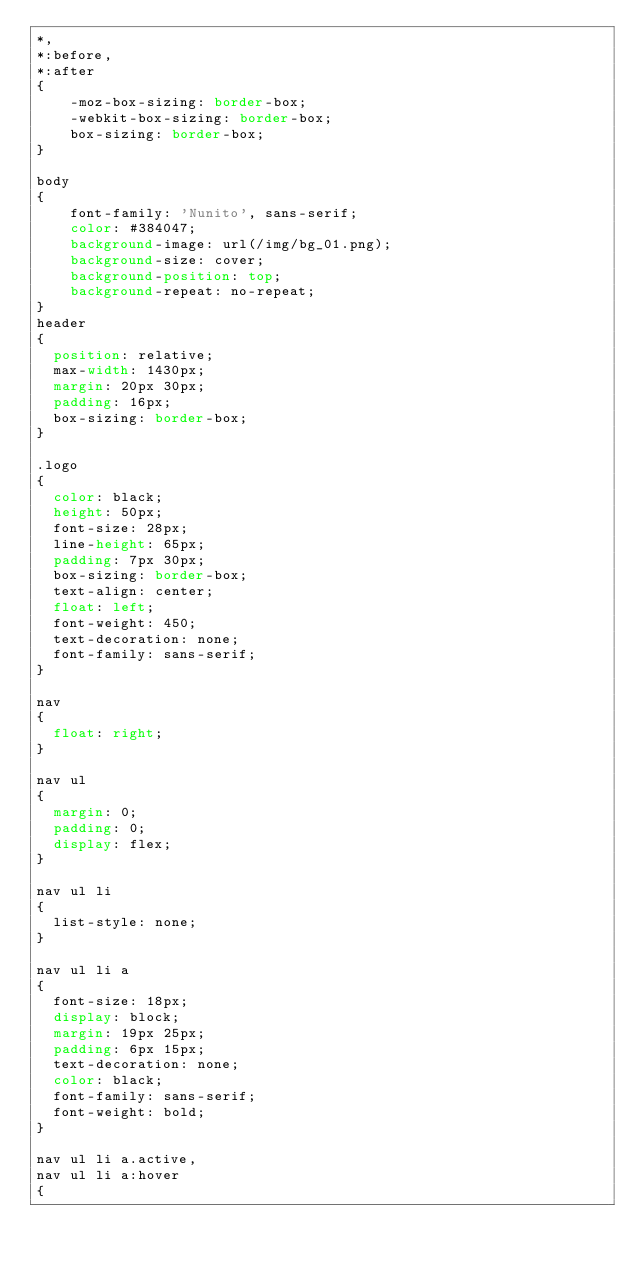Convert code to text. <code><loc_0><loc_0><loc_500><loc_500><_CSS_>*,
*:before,
*:after 
{
    -moz-box-sizing: border-box;
    -webkit-box-sizing: border-box;
    box-sizing: border-box;
}

body 
{
    font-family: 'Nunito', sans-serif;
    color: #384047;
    background-image: url(/img/bg_01.png);
    background-size: cover;
    background-position: top;
    background-repeat: no-repeat;
}
header
{
  position: relative;
  max-width: 1430px;
  margin: 20px 30px;
  padding: 16px;
  box-sizing: border-box;
}

.logo
{
  color: black;
  height: 50px;
  font-size: 28px;
  line-height: 65px;
  padding: 7px 30px;
  box-sizing: border-box;
  text-align: center;
  float: left;
  font-weight: 450;
  text-decoration: none;
  font-family: sans-serif;
}

nav
{
  float: right;
}

nav ul
{
  margin: 0;
  padding: 0;
  display: flex;
}

nav ul li
{
  list-style: none;
}

nav ul li a
{
  font-size: 18px;
  display: block;
  margin: 19px 25px;
  padding: 6px 15px;
  text-decoration: none;
  color: black;
  font-family: sans-serif;
  font-weight: bold;
}

nav ul li a.active, 
nav ul li a:hover
{</code> 